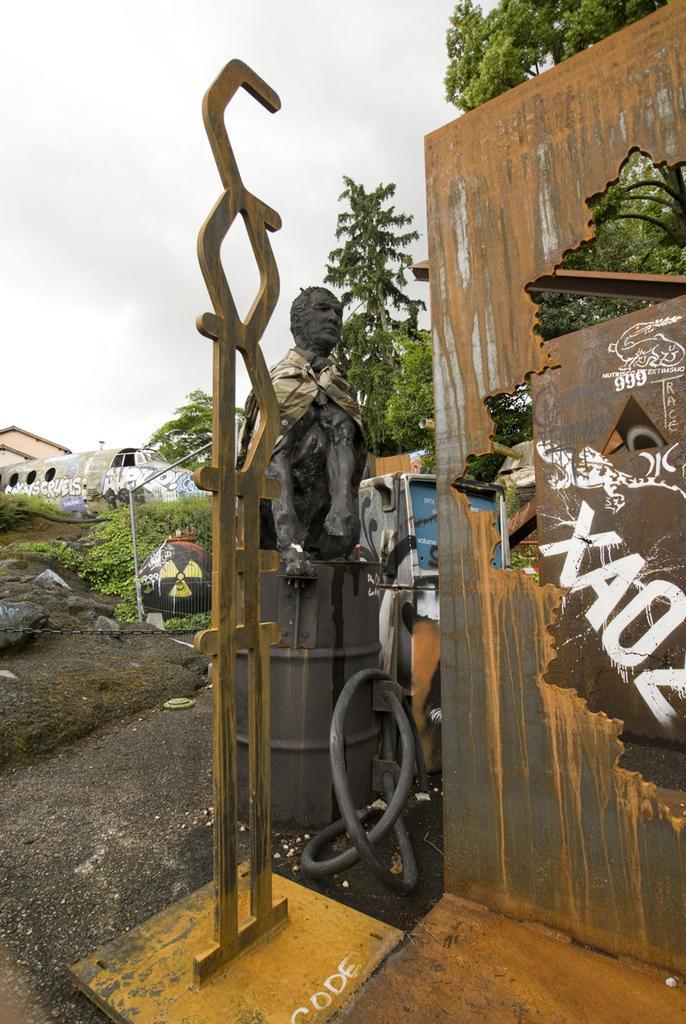Please provide a concise description of this image. In the front of the image there is a statue and objects. In the background of the image there are trees, vehicle, pole, chain, cloudy sky, rocks and objects. 